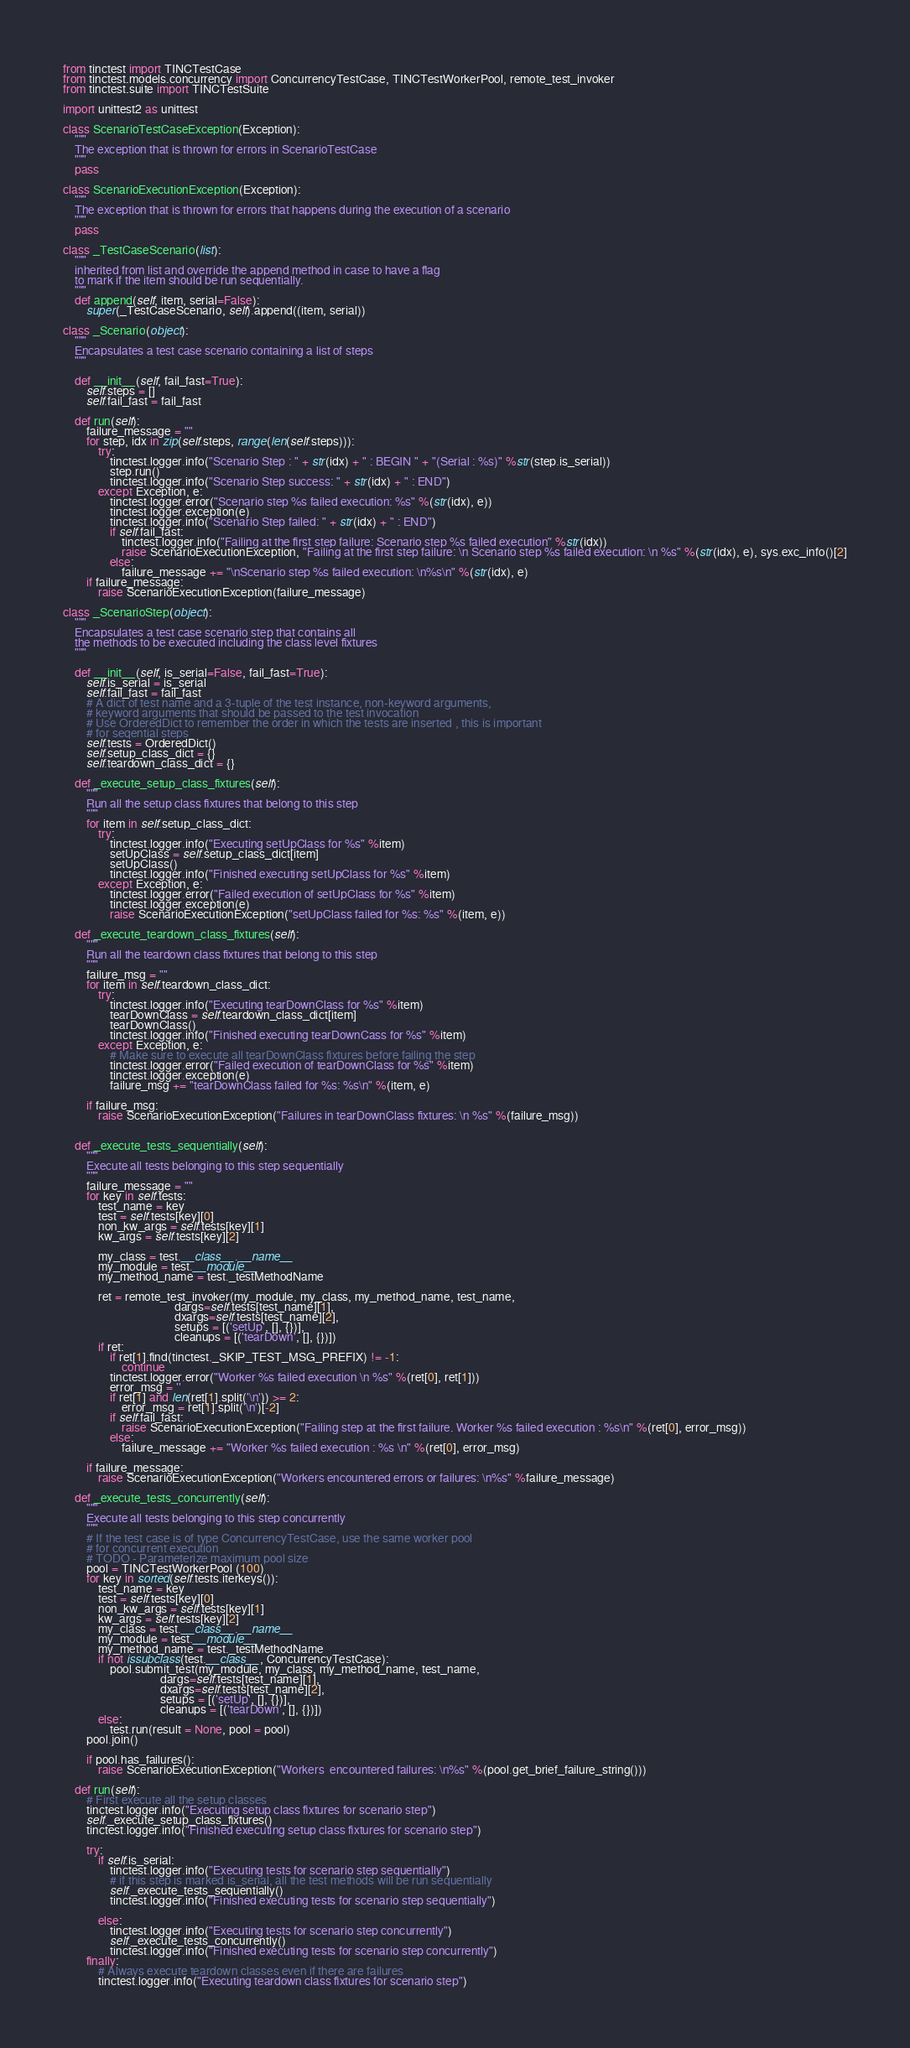Convert code to text. <code><loc_0><loc_0><loc_500><loc_500><_Python_>from tinctest import TINCTestCase
from tinctest.models.concurrency import ConcurrencyTestCase, TINCTestWorkerPool, remote_test_invoker
from tinctest.suite import TINCTestSuite

import unittest2 as unittest

class ScenarioTestCaseException(Exception):
    """
    The exception that is thrown for errors in ScenarioTestCase
    """
    pass

class ScenarioExecutionException(Exception):
    """
    The exception that is thrown for errors that happens during the execution of a scenario
    """
    pass

class _TestCaseScenario(list):
    """
    inherited from list and override the append method in case to have a flag
    to mark if the item should be run sequentially.
    """
    def append(self, item, serial=False):
        super(_TestCaseScenario, self).append((item, serial))

class _Scenario(object):
    """
    Encapsulates a test case scenario containing a list of steps
    """

    def __init__(self, fail_fast=True):
        self.steps = []
        self.fail_fast = fail_fast

    def run(self):
        failure_message = ""
        for step, idx in zip(self.steps, range(len(self.steps))):
            try:
                tinctest.logger.info("Scenario Step : " + str(idx) + " : BEGIN " + "(Serial : %s)" %str(step.is_serial))
                step.run()
                tinctest.logger.info("Scenario Step success: " + str(idx) + " : END")
            except Exception, e:
                tinctest.logger.error("Scenario step %s failed execution: %s" %(str(idx), e))
                tinctest.logger.exception(e)
                tinctest.logger.info("Scenario Step failed: " + str(idx) + " : END")
                if self.fail_fast:
                    tinctest.logger.info("Failing at the first step failure: Scenario step %s failed execution" %str(idx))
                    raise ScenarioExecutionException, "Failing at the first step failure: \n Scenario step %s failed execution: \n %s" %(str(idx), e), sys.exc_info()[2]
                else:
                    failure_message += "\nScenario step %s failed execution: \n%s\n" %(str(idx), e)
        if failure_message:
            raise ScenarioExecutionException(failure_message)

class _ScenarioStep(object):
    """
    Encapsulates a test case scenario step that contains all
    the methods to be executed including the class level fixtures
    """

    def __init__(self, is_serial=False, fail_fast=True):
        self.is_serial = is_serial
        self.fail_fast = fail_fast
        # A dict of test name and a 3-tuple of the test instance, non-keyword arguments,
        # keyword arguments that should be passed to the test invocation
        # Use OrderedDict to remember the order in which the tests are inserted , this is important
        # for seqential steps
        self.tests = OrderedDict()
        self.setup_class_dict = {}
        self.teardown_class_dict = {}

    def _execute_setup_class_fixtures(self):
        """
        Run all the setup class fixtures that belong to this step
        """
        for item in self.setup_class_dict:
            try:
                tinctest.logger.info("Executing setUpClass for %s" %item)
                setUpClass = self.setup_class_dict[item]
                setUpClass()
                tinctest.logger.info("Finished executing setUpClass for %s" %item)
            except Exception, e:
                tinctest.logger.error("Failed execution of setUpClass for %s" %item)
                tinctest.logger.exception(e)
                raise ScenarioExecutionException("setUpClass failed for %s: %s" %(item, e))
            
    def _execute_teardown_class_fixtures(self):
        """
        Run all the teardown class fixtures that belong to this step
        """
        failure_msg = ""
        for item in self.teardown_class_dict:
            try:
                tinctest.logger.info("Executing tearDownClass for %s" %item)
                tearDownClass = self.teardown_class_dict[item]
                tearDownClass()
                tinctest.logger.info("Finished executing tearDownCass for %s" %item)
            except Exception, e:
                # Make sure to execute all tearDownClass fixtures before failing the step
                tinctest.logger.error("Failed execution of tearDownClass for %s" %item)
                tinctest.logger.exception(e)
                failure_msg += "tearDownClass failed for %s: %s\n" %(item, e)

        if failure_msg:
            raise ScenarioExecutionException("Failures in tearDownClass fixtures: \n %s" %(failure_msg))
                

    def _execute_tests_sequentially(self):
        """
        Execute all tests belonging to this step sequentially
        """
        failure_message = ""
        for key in self.tests:
            test_name = key
            test = self.tests[key][0]
            non_kw_args = self.tests[key][1]
            kw_args = self.tests[key][2]
            
            my_class = test.__class__.__name__
            my_module = test.__module__
            my_method_name = test._testMethodName

            ret = remote_test_invoker(my_module, my_class, my_method_name, test_name,
                                      dargs=self.tests[test_name][1],
                                      dxargs=self.tests[test_name][2],
                                      setups = [('setUp', [], {})],
                                      cleanups = [('tearDown', [], {})])
            if ret:
                if ret[1].find(tinctest._SKIP_TEST_MSG_PREFIX) != -1:
                    continue
                tinctest.logger.error("Worker %s failed execution \n %s" %(ret[0], ret[1]))
                error_msg = ''
                if ret[1] and len(ret[1].split('\n')) >= 2:
                    error_msg = ret[1].split('\n')[-2]
                if self.fail_fast:
                    raise ScenarioExecutionException("Failing step at the first failure. Worker %s failed execution : %s\n" %(ret[0], error_msg))
                else:
                    failure_message += "Worker %s failed execution : %s \n" %(ret[0], error_msg)

        if failure_message:
            raise ScenarioExecutionException("Workers encountered errors or failures: \n%s" %failure_message)

    def _execute_tests_concurrently(self):
        """
        Execute all tests belonging to this step concurrently
        """
        # If the test case is of type ConcurrencyTestCase, use the same worker pool
        # for concurrent execution
        # TODO - Parameterize maximum pool size
        pool = TINCTestWorkerPool (100)
        for key in sorted(self.tests.iterkeys()):
            test_name = key
            test = self.tests[key][0]
            non_kw_args = self.tests[key][1]
            kw_args = self.tests[key][2]
            my_class = test.__class__.__name__
            my_module = test.__module__
            my_method_name = test._testMethodName
            if not issubclass(test.__class__, ConcurrencyTestCase):
                pool.submit_test(my_module, my_class, my_method_name, test_name,
                                 dargs=self.tests[test_name][1],
                                 dxargs=self.tests[test_name][2],
                                 setups = [('setUp', [], {})],
                                 cleanups = [('tearDown', [], {})])
            else:
                test.run(result = None, pool = pool)
        pool.join()

        if pool.has_failures():
            raise ScenarioExecutionException("Workers  encountered failures: \n%s" %(pool.get_brief_failure_string()))

    def run(self):
        # First execute all the setup classes
        tinctest.logger.info("Executing setup class fixtures for scenario step")
        self._execute_setup_class_fixtures()
        tinctest.logger.info("Finished executing setup class fixtures for scenario step")

        try:
            if self.is_serial:
                tinctest.logger.info("Executing tests for scenario step sequentially")
                # if this step is marked is_serial, all the test methods will be run sequentially
                self._execute_tests_sequentially()
                tinctest.logger.info("Finished executing tests for scenario step sequentially")
        
            else:
                tinctest.logger.info("Executing tests for scenario step concurrently")
                self._execute_tests_concurrently()
                tinctest.logger.info("Finished executing tests for scenario step concurrently")
        finally:
            # Always execute teardown classes even if there are failures
            tinctest.logger.info("Executing teardown class fixtures for scenario step")</code> 